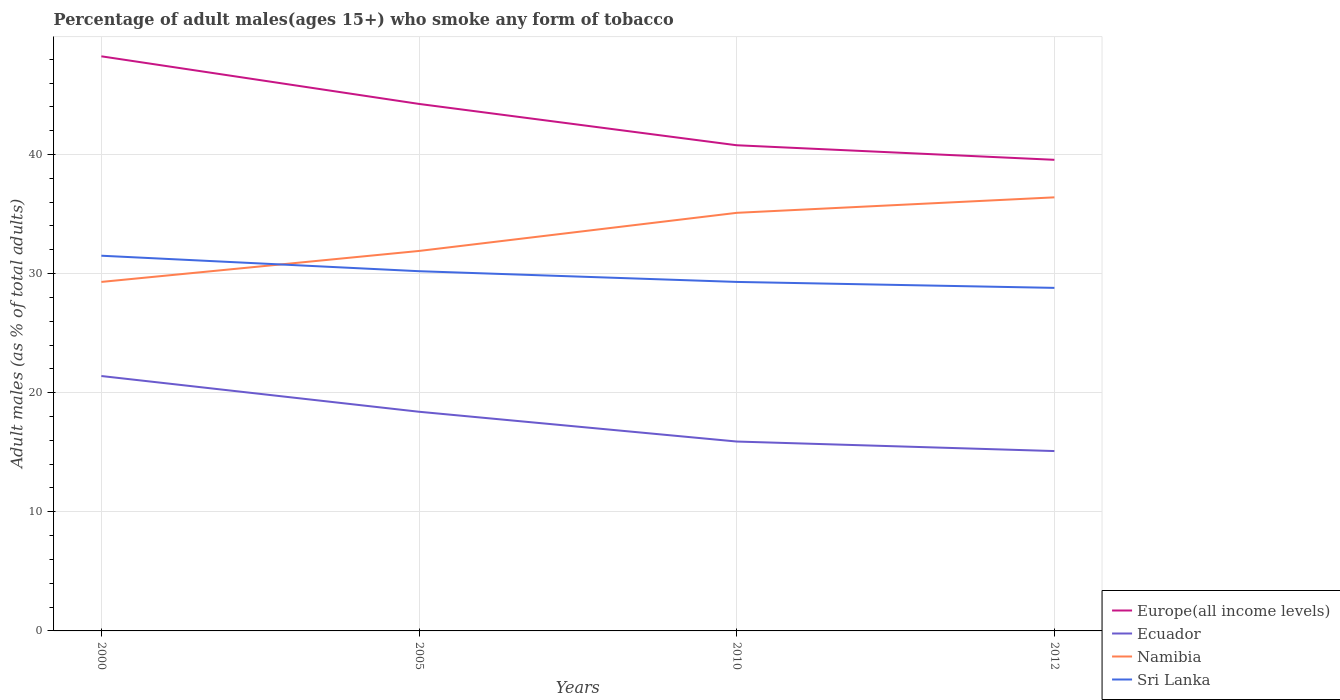Does the line corresponding to Europe(all income levels) intersect with the line corresponding to Sri Lanka?
Give a very brief answer. No. Across all years, what is the maximum percentage of adult males who smoke in Europe(all income levels)?
Provide a succinct answer. 39.55. What is the total percentage of adult males who smoke in Europe(all income levels) in the graph?
Offer a very short reply. 3.47. What is the difference between the highest and the second highest percentage of adult males who smoke in Sri Lanka?
Provide a succinct answer. 2.7. How many lines are there?
Your answer should be compact. 4. How many years are there in the graph?
Make the answer very short. 4. Are the values on the major ticks of Y-axis written in scientific E-notation?
Provide a succinct answer. No. Does the graph contain any zero values?
Keep it short and to the point. No. How many legend labels are there?
Keep it short and to the point. 4. What is the title of the graph?
Offer a very short reply. Percentage of adult males(ages 15+) who smoke any form of tobacco. Does "Honduras" appear as one of the legend labels in the graph?
Keep it short and to the point. No. What is the label or title of the X-axis?
Keep it short and to the point. Years. What is the label or title of the Y-axis?
Give a very brief answer. Adult males (as % of total adults). What is the Adult males (as % of total adults) in Europe(all income levels) in 2000?
Provide a short and direct response. 48.24. What is the Adult males (as % of total adults) in Ecuador in 2000?
Offer a very short reply. 21.4. What is the Adult males (as % of total adults) in Namibia in 2000?
Provide a short and direct response. 29.3. What is the Adult males (as % of total adults) of Sri Lanka in 2000?
Give a very brief answer. 31.5. What is the Adult males (as % of total adults) in Europe(all income levels) in 2005?
Offer a terse response. 44.24. What is the Adult males (as % of total adults) in Namibia in 2005?
Offer a terse response. 31.9. What is the Adult males (as % of total adults) in Sri Lanka in 2005?
Your answer should be compact. 30.2. What is the Adult males (as % of total adults) of Europe(all income levels) in 2010?
Ensure brevity in your answer.  40.77. What is the Adult males (as % of total adults) in Ecuador in 2010?
Provide a short and direct response. 15.9. What is the Adult males (as % of total adults) of Namibia in 2010?
Make the answer very short. 35.1. What is the Adult males (as % of total adults) in Sri Lanka in 2010?
Your answer should be very brief. 29.3. What is the Adult males (as % of total adults) of Europe(all income levels) in 2012?
Give a very brief answer. 39.55. What is the Adult males (as % of total adults) in Ecuador in 2012?
Ensure brevity in your answer.  15.1. What is the Adult males (as % of total adults) in Namibia in 2012?
Offer a terse response. 36.4. What is the Adult males (as % of total adults) in Sri Lanka in 2012?
Offer a very short reply. 28.8. Across all years, what is the maximum Adult males (as % of total adults) of Europe(all income levels)?
Your response must be concise. 48.24. Across all years, what is the maximum Adult males (as % of total adults) in Ecuador?
Make the answer very short. 21.4. Across all years, what is the maximum Adult males (as % of total adults) of Namibia?
Provide a succinct answer. 36.4. Across all years, what is the maximum Adult males (as % of total adults) of Sri Lanka?
Offer a terse response. 31.5. Across all years, what is the minimum Adult males (as % of total adults) of Europe(all income levels)?
Provide a short and direct response. 39.55. Across all years, what is the minimum Adult males (as % of total adults) in Ecuador?
Your response must be concise. 15.1. Across all years, what is the minimum Adult males (as % of total adults) in Namibia?
Provide a succinct answer. 29.3. Across all years, what is the minimum Adult males (as % of total adults) in Sri Lanka?
Offer a terse response. 28.8. What is the total Adult males (as % of total adults) of Europe(all income levels) in the graph?
Your answer should be compact. 172.81. What is the total Adult males (as % of total adults) of Ecuador in the graph?
Keep it short and to the point. 70.8. What is the total Adult males (as % of total adults) in Namibia in the graph?
Provide a succinct answer. 132.7. What is the total Adult males (as % of total adults) of Sri Lanka in the graph?
Make the answer very short. 119.8. What is the difference between the Adult males (as % of total adults) of Europe(all income levels) in 2000 and that in 2005?
Your answer should be compact. 4. What is the difference between the Adult males (as % of total adults) of Ecuador in 2000 and that in 2005?
Make the answer very short. 3. What is the difference between the Adult males (as % of total adults) of Namibia in 2000 and that in 2005?
Provide a short and direct response. -2.6. What is the difference between the Adult males (as % of total adults) in Europe(all income levels) in 2000 and that in 2010?
Provide a short and direct response. 7.47. What is the difference between the Adult males (as % of total adults) of Europe(all income levels) in 2000 and that in 2012?
Provide a succinct answer. 8.69. What is the difference between the Adult males (as % of total adults) of Namibia in 2000 and that in 2012?
Offer a very short reply. -7.1. What is the difference between the Adult males (as % of total adults) in Sri Lanka in 2000 and that in 2012?
Give a very brief answer. 2.7. What is the difference between the Adult males (as % of total adults) in Europe(all income levels) in 2005 and that in 2010?
Your answer should be compact. 3.47. What is the difference between the Adult males (as % of total adults) of Ecuador in 2005 and that in 2010?
Your response must be concise. 2.5. What is the difference between the Adult males (as % of total adults) of Sri Lanka in 2005 and that in 2010?
Give a very brief answer. 0.9. What is the difference between the Adult males (as % of total adults) in Europe(all income levels) in 2005 and that in 2012?
Provide a short and direct response. 4.69. What is the difference between the Adult males (as % of total adults) of Ecuador in 2005 and that in 2012?
Ensure brevity in your answer.  3.3. What is the difference between the Adult males (as % of total adults) in Namibia in 2005 and that in 2012?
Offer a very short reply. -4.5. What is the difference between the Adult males (as % of total adults) in Sri Lanka in 2005 and that in 2012?
Ensure brevity in your answer.  1.4. What is the difference between the Adult males (as % of total adults) in Europe(all income levels) in 2010 and that in 2012?
Offer a terse response. 1.22. What is the difference between the Adult males (as % of total adults) of Europe(all income levels) in 2000 and the Adult males (as % of total adults) of Ecuador in 2005?
Offer a very short reply. 29.84. What is the difference between the Adult males (as % of total adults) in Europe(all income levels) in 2000 and the Adult males (as % of total adults) in Namibia in 2005?
Your response must be concise. 16.34. What is the difference between the Adult males (as % of total adults) of Europe(all income levels) in 2000 and the Adult males (as % of total adults) of Sri Lanka in 2005?
Keep it short and to the point. 18.04. What is the difference between the Adult males (as % of total adults) of Ecuador in 2000 and the Adult males (as % of total adults) of Namibia in 2005?
Give a very brief answer. -10.5. What is the difference between the Adult males (as % of total adults) in Ecuador in 2000 and the Adult males (as % of total adults) in Sri Lanka in 2005?
Keep it short and to the point. -8.8. What is the difference between the Adult males (as % of total adults) of Europe(all income levels) in 2000 and the Adult males (as % of total adults) of Ecuador in 2010?
Offer a very short reply. 32.34. What is the difference between the Adult males (as % of total adults) of Europe(all income levels) in 2000 and the Adult males (as % of total adults) of Namibia in 2010?
Your response must be concise. 13.14. What is the difference between the Adult males (as % of total adults) in Europe(all income levels) in 2000 and the Adult males (as % of total adults) in Sri Lanka in 2010?
Give a very brief answer. 18.94. What is the difference between the Adult males (as % of total adults) of Ecuador in 2000 and the Adult males (as % of total adults) of Namibia in 2010?
Keep it short and to the point. -13.7. What is the difference between the Adult males (as % of total adults) of Namibia in 2000 and the Adult males (as % of total adults) of Sri Lanka in 2010?
Offer a very short reply. 0. What is the difference between the Adult males (as % of total adults) of Europe(all income levels) in 2000 and the Adult males (as % of total adults) of Ecuador in 2012?
Offer a terse response. 33.14. What is the difference between the Adult males (as % of total adults) in Europe(all income levels) in 2000 and the Adult males (as % of total adults) in Namibia in 2012?
Give a very brief answer. 11.84. What is the difference between the Adult males (as % of total adults) of Europe(all income levels) in 2000 and the Adult males (as % of total adults) of Sri Lanka in 2012?
Provide a succinct answer. 19.44. What is the difference between the Adult males (as % of total adults) of Ecuador in 2000 and the Adult males (as % of total adults) of Sri Lanka in 2012?
Provide a succinct answer. -7.4. What is the difference between the Adult males (as % of total adults) in Europe(all income levels) in 2005 and the Adult males (as % of total adults) in Ecuador in 2010?
Your answer should be very brief. 28.34. What is the difference between the Adult males (as % of total adults) in Europe(all income levels) in 2005 and the Adult males (as % of total adults) in Namibia in 2010?
Provide a short and direct response. 9.14. What is the difference between the Adult males (as % of total adults) in Europe(all income levels) in 2005 and the Adult males (as % of total adults) in Sri Lanka in 2010?
Ensure brevity in your answer.  14.94. What is the difference between the Adult males (as % of total adults) in Ecuador in 2005 and the Adult males (as % of total adults) in Namibia in 2010?
Provide a short and direct response. -16.7. What is the difference between the Adult males (as % of total adults) in Europe(all income levels) in 2005 and the Adult males (as % of total adults) in Ecuador in 2012?
Offer a terse response. 29.14. What is the difference between the Adult males (as % of total adults) in Europe(all income levels) in 2005 and the Adult males (as % of total adults) in Namibia in 2012?
Keep it short and to the point. 7.84. What is the difference between the Adult males (as % of total adults) of Europe(all income levels) in 2005 and the Adult males (as % of total adults) of Sri Lanka in 2012?
Offer a very short reply. 15.44. What is the difference between the Adult males (as % of total adults) in Ecuador in 2005 and the Adult males (as % of total adults) in Namibia in 2012?
Ensure brevity in your answer.  -18. What is the difference between the Adult males (as % of total adults) of Namibia in 2005 and the Adult males (as % of total adults) of Sri Lanka in 2012?
Your answer should be very brief. 3.1. What is the difference between the Adult males (as % of total adults) of Europe(all income levels) in 2010 and the Adult males (as % of total adults) of Ecuador in 2012?
Give a very brief answer. 25.67. What is the difference between the Adult males (as % of total adults) of Europe(all income levels) in 2010 and the Adult males (as % of total adults) of Namibia in 2012?
Provide a succinct answer. 4.37. What is the difference between the Adult males (as % of total adults) of Europe(all income levels) in 2010 and the Adult males (as % of total adults) of Sri Lanka in 2012?
Provide a short and direct response. 11.97. What is the difference between the Adult males (as % of total adults) of Ecuador in 2010 and the Adult males (as % of total adults) of Namibia in 2012?
Make the answer very short. -20.5. What is the average Adult males (as % of total adults) of Europe(all income levels) per year?
Offer a very short reply. 43.2. What is the average Adult males (as % of total adults) in Namibia per year?
Your answer should be very brief. 33.17. What is the average Adult males (as % of total adults) of Sri Lanka per year?
Provide a short and direct response. 29.95. In the year 2000, what is the difference between the Adult males (as % of total adults) in Europe(all income levels) and Adult males (as % of total adults) in Ecuador?
Provide a short and direct response. 26.84. In the year 2000, what is the difference between the Adult males (as % of total adults) of Europe(all income levels) and Adult males (as % of total adults) of Namibia?
Your response must be concise. 18.94. In the year 2000, what is the difference between the Adult males (as % of total adults) in Europe(all income levels) and Adult males (as % of total adults) in Sri Lanka?
Your response must be concise. 16.74. In the year 2000, what is the difference between the Adult males (as % of total adults) of Ecuador and Adult males (as % of total adults) of Namibia?
Offer a very short reply. -7.9. In the year 2000, what is the difference between the Adult males (as % of total adults) in Namibia and Adult males (as % of total adults) in Sri Lanka?
Give a very brief answer. -2.2. In the year 2005, what is the difference between the Adult males (as % of total adults) in Europe(all income levels) and Adult males (as % of total adults) in Ecuador?
Make the answer very short. 25.84. In the year 2005, what is the difference between the Adult males (as % of total adults) in Europe(all income levels) and Adult males (as % of total adults) in Namibia?
Your response must be concise. 12.34. In the year 2005, what is the difference between the Adult males (as % of total adults) in Europe(all income levels) and Adult males (as % of total adults) in Sri Lanka?
Make the answer very short. 14.04. In the year 2010, what is the difference between the Adult males (as % of total adults) of Europe(all income levels) and Adult males (as % of total adults) of Ecuador?
Make the answer very short. 24.87. In the year 2010, what is the difference between the Adult males (as % of total adults) in Europe(all income levels) and Adult males (as % of total adults) in Namibia?
Your response must be concise. 5.67. In the year 2010, what is the difference between the Adult males (as % of total adults) of Europe(all income levels) and Adult males (as % of total adults) of Sri Lanka?
Provide a succinct answer. 11.47. In the year 2010, what is the difference between the Adult males (as % of total adults) of Ecuador and Adult males (as % of total adults) of Namibia?
Your answer should be very brief. -19.2. In the year 2010, what is the difference between the Adult males (as % of total adults) in Ecuador and Adult males (as % of total adults) in Sri Lanka?
Ensure brevity in your answer.  -13.4. In the year 2012, what is the difference between the Adult males (as % of total adults) of Europe(all income levels) and Adult males (as % of total adults) of Ecuador?
Provide a short and direct response. 24.45. In the year 2012, what is the difference between the Adult males (as % of total adults) in Europe(all income levels) and Adult males (as % of total adults) in Namibia?
Ensure brevity in your answer.  3.15. In the year 2012, what is the difference between the Adult males (as % of total adults) of Europe(all income levels) and Adult males (as % of total adults) of Sri Lanka?
Your answer should be very brief. 10.75. In the year 2012, what is the difference between the Adult males (as % of total adults) of Ecuador and Adult males (as % of total adults) of Namibia?
Offer a terse response. -21.3. In the year 2012, what is the difference between the Adult males (as % of total adults) in Ecuador and Adult males (as % of total adults) in Sri Lanka?
Ensure brevity in your answer.  -13.7. In the year 2012, what is the difference between the Adult males (as % of total adults) of Namibia and Adult males (as % of total adults) of Sri Lanka?
Keep it short and to the point. 7.6. What is the ratio of the Adult males (as % of total adults) in Europe(all income levels) in 2000 to that in 2005?
Your answer should be very brief. 1.09. What is the ratio of the Adult males (as % of total adults) in Ecuador in 2000 to that in 2005?
Your answer should be compact. 1.16. What is the ratio of the Adult males (as % of total adults) of Namibia in 2000 to that in 2005?
Give a very brief answer. 0.92. What is the ratio of the Adult males (as % of total adults) of Sri Lanka in 2000 to that in 2005?
Provide a short and direct response. 1.04. What is the ratio of the Adult males (as % of total adults) in Europe(all income levels) in 2000 to that in 2010?
Your answer should be very brief. 1.18. What is the ratio of the Adult males (as % of total adults) of Ecuador in 2000 to that in 2010?
Offer a very short reply. 1.35. What is the ratio of the Adult males (as % of total adults) of Namibia in 2000 to that in 2010?
Give a very brief answer. 0.83. What is the ratio of the Adult males (as % of total adults) in Sri Lanka in 2000 to that in 2010?
Keep it short and to the point. 1.08. What is the ratio of the Adult males (as % of total adults) of Europe(all income levels) in 2000 to that in 2012?
Offer a very short reply. 1.22. What is the ratio of the Adult males (as % of total adults) of Ecuador in 2000 to that in 2012?
Your answer should be compact. 1.42. What is the ratio of the Adult males (as % of total adults) in Namibia in 2000 to that in 2012?
Give a very brief answer. 0.8. What is the ratio of the Adult males (as % of total adults) in Sri Lanka in 2000 to that in 2012?
Provide a short and direct response. 1.09. What is the ratio of the Adult males (as % of total adults) of Europe(all income levels) in 2005 to that in 2010?
Your answer should be compact. 1.09. What is the ratio of the Adult males (as % of total adults) in Ecuador in 2005 to that in 2010?
Offer a terse response. 1.16. What is the ratio of the Adult males (as % of total adults) in Namibia in 2005 to that in 2010?
Make the answer very short. 0.91. What is the ratio of the Adult males (as % of total adults) of Sri Lanka in 2005 to that in 2010?
Your answer should be very brief. 1.03. What is the ratio of the Adult males (as % of total adults) of Europe(all income levels) in 2005 to that in 2012?
Offer a terse response. 1.12. What is the ratio of the Adult males (as % of total adults) in Ecuador in 2005 to that in 2012?
Your answer should be compact. 1.22. What is the ratio of the Adult males (as % of total adults) in Namibia in 2005 to that in 2012?
Offer a terse response. 0.88. What is the ratio of the Adult males (as % of total adults) in Sri Lanka in 2005 to that in 2012?
Offer a very short reply. 1.05. What is the ratio of the Adult males (as % of total adults) in Europe(all income levels) in 2010 to that in 2012?
Your response must be concise. 1.03. What is the ratio of the Adult males (as % of total adults) in Ecuador in 2010 to that in 2012?
Ensure brevity in your answer.  1.05. What is the ratio of the Adult males (as % of total adults) in Sri Lanka in 2010 to that in 2012?
Provide a succinct answer. 1.02. What is the difference between the highest and the second highest Adult males (as % of total adults) of Europe(all income levels)?
Keep it short and to the point. 4. What is the difference between the highest and the second highest Adult males (as % of total adults) of Sri Lanka?
Offer a very short reply. 1.3. What is the difference between the highest and the lowest Adult males (as % of total adults) in Europe(all income levels)?
Keep it short and to the point. 8.69. What is the difference between the highest and the lowest Adult males (as % of total adults) in Ecuador?
Give a very brief answer. 6.3. 